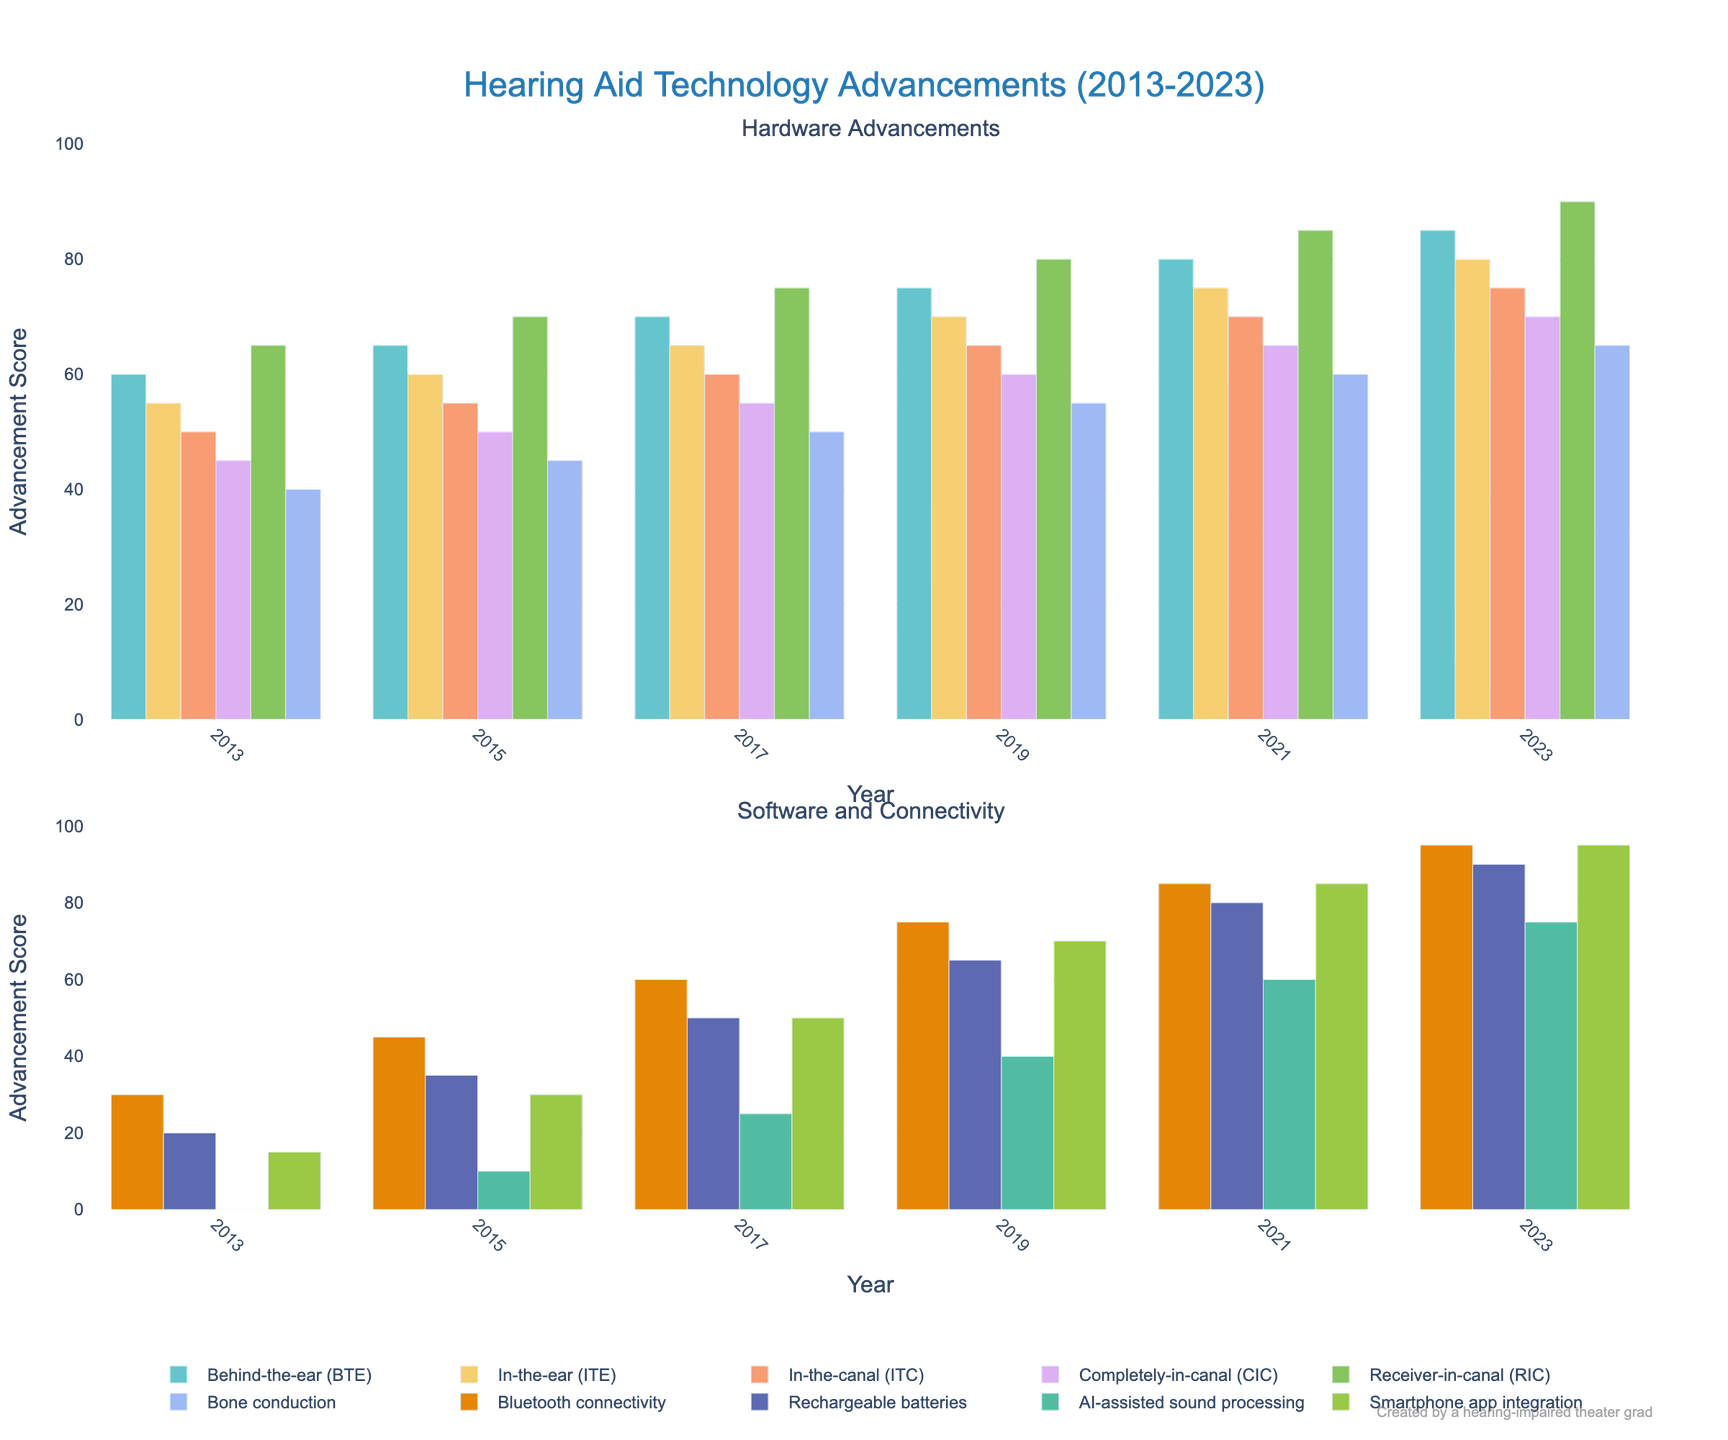Which hearing aid type saw the most significant advancement in 2015? Looking at the bars for 2015, the tallest bar represents the most significant advancement. Bluetooth connectivity has the highest score in 2015, showing the most significant advancement.
Answer: Bluetooth connectivity In 2023, which type of hearing aid technology has the highest advancement score? In 2023, Bluetooth connectivity and Smartphone app integration have the highest bars, indicating the highest scores. Their value is 95.
Answer: Bluetooth connectivity and Smartphone app integration What is the increase in the advancement score for Behind-the-ear (BTE) hearing aids from 2013 to 2023? The score for BTE in 2013 is 60 and in 2023 is 85. The increase is 85 - 60.
Answer: 25 Which hardware type of hearing aid saw the least advancement from 2013 to 2023? Look at the difference in scores for all hardware types (BTE, ITE, ITC, CIC, RIC, Bone conduction). Bone conduction has the smallest increase from 40 to 65, which is 25.
Answer: Bone conduction From 2013 to 2023, how much did AI-assisted sound processing advance? The advancement score for AI-assisted sound processing in 2013 is 0 and in 2023 is 75. The increase is 75 - 0.
Answer: 75 Which year saw a major advancement in rechargeable batteries, and what was the increase from the previous data point? Rechargeable batteries advanced significantly in 2017 with a score of 50. The previous data point (2015) was 35. The increase is 50 - 35.
Answer: 2017, 15 How does the advancement score in 2023 for Completely-in-canal (CIC) hearing aids compare to In-the-canal (ITC) hearing aids in 2017? In CIC, the 2023 score is 70, and for ITC in 2017, the score is 60.
Answer: CIC 2023 is higher by 10 Which type of hearing aid technology showed consistent improvement every two years from 2013 to 2023? Observing the bars, Behind-the-ear (BTE), In-the-ear (ITE), In-the-canal (ITC), Completely-in-canal (CIC), Receiver-in-canal (RIC), Bone conduction, Bluetooth connectivity, Rechargeable batteries, AI-assisted sound processing, and Smartphone app integration all show consistent improvements every two years.
Answer: All types What is the average advancement score of Smartphone app integration from 2015 to 2023? The scores are [30, 50, 70, 85, 95]. The sum is 330, so the average score is 330/5.
Answer: 66 What is the difference in the highest and lowest advancement scores in 2023 among all types? The highest score in 2023 is 95 (Bluetooth connectivity and Smartphone app integration), and the lowest is 65 (Bone conduction). The difference is 95 - 65.
Answer: 30 